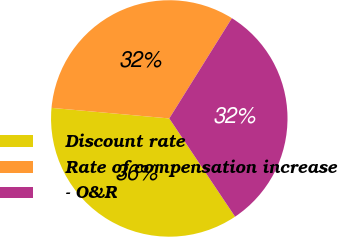Convert chart. <chart><loc_0><loc_0><loc_500><loc_500><pie_chart><fcel>Discount rate<fcel>Rate of compensation increase<fcel>- O&R<nl><fcel>35.82%<fcel>32.46%<fcel>31.72%<nl></chart> 